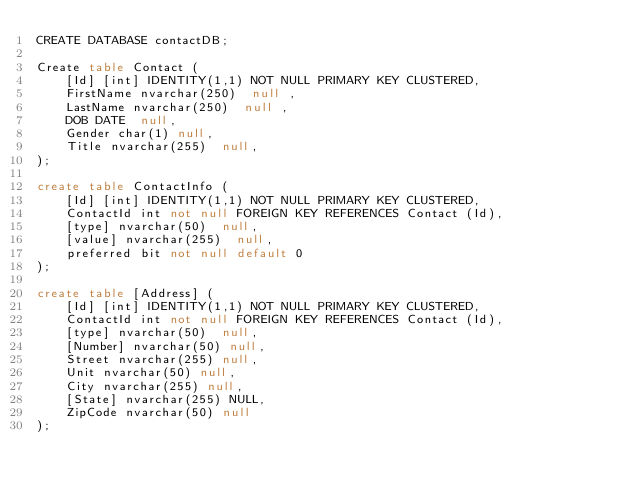Convert code to text. <code><loc_0><loc_0><loc_500><loc_500><_SQL_>CREATE DATABASE contactDB;

Create table Contact (
    [Id] [int] IDENTITY(1,1) NOT NULL PRIMARY KEY CLUSTERED,
    FirstName nvarchar(250)  null ,
    LastName nvarchar(250)  null ,
    DOB DATE  null,
    Gender char(1) null,
    Title nvarchar(255)  null,
);

create table ContactInfo (
    [Id] [int] IDENTITY(1,1) NOT NULL PRIMARY KEY CLUSTERED,
    ContactId int not null FOREIGN KEY REFERENCES Contact (Id),
    [type] nvarchar(50)  null, 
    [value] nvarchar(255)  null,
    preferred bit not null default 0
);

create table [Address] (
    [Id] [int] IDENTITY(1,1) NOT NULL PRIMARY KEY CLUSTERED,
    ContactId int not null FOREIGN KEY REFERENCES Contact (Id),
    [type] nvarchar(50)  null,
    [Number] nvarchar(50) null,
    Street nvarchar(255) null,
    Unit nvarchar(50) null,
    City nvarchar(255) null,
    [State] nvarchar(255) NULL,
    ZipCode nvarchar(50) null
);
</code> 